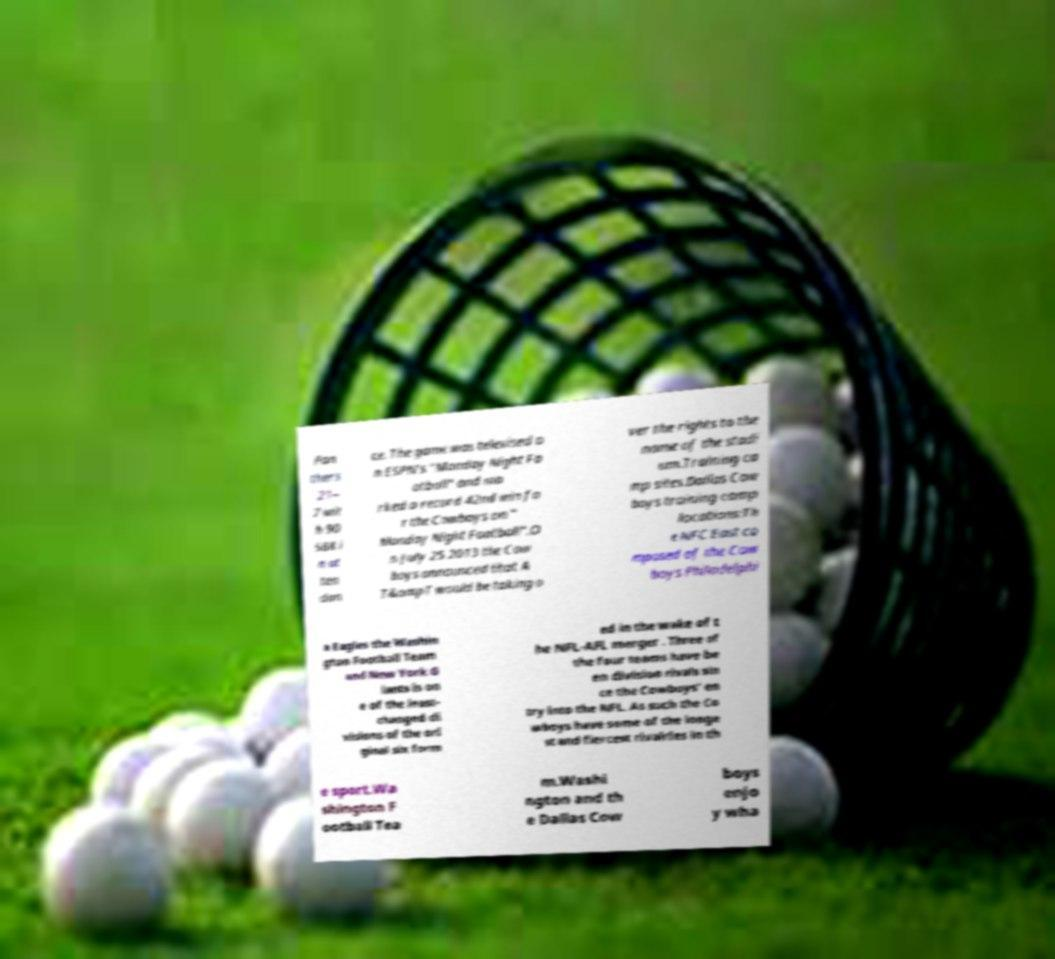Could you assist in decoding the text presented in this image and type it out clearly? Pan thers 21– 7 wit h 90 588 i n at ten dan ce. The game was televised o n ESPN's "Monday Night Fo otball" and ma rked a record 42nd win fo r the Cowboys on " Monday Night Football".O n July 25 2013 the Cow boys announced that A T&ampT would be taking o ver the rights to the name of the stadi um.Training ca mp sites.Dallas Cow boys training camp locations:Th e NFC East co mposed of the Cow boys Philadelphi a Eagles the Washin gton Football Team and New York G iants is on e of the least- changed di visions of the ori ginal six form ed in the wake of t he NFL-AFL merger . Three of the four teams have be en division rivals sin ce the Cowboys' en try into the NFL. As such the Co wboys have some of the longe st and fiercest rivalries in th e sport.Wa shington F ootball Tea m.Washi ngton and th e Dallas Cow boys enjo y wha 